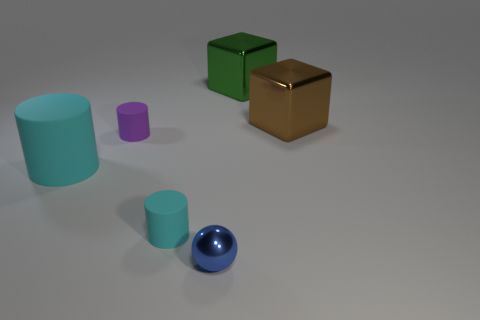There is a sphere that is the same size as the purple thing; what color is it?
Ensure brevity in your answer.  Blue. What size is the shiny object behind the large brown object?
Provide a short and direct response. Large. There is a big object on the left side of the blue ball; is there a tiny cyan cylinder on the right side of it?
Make the answer very short. Yes. Is the cyan cylinder right of the large cylinder made of the same material as the sphere?
Your response must be concise. No. What number of things are both to the right of the small cyan matte object and in front of the big brown thing?
Your answer should be compact. 1. What number of tiny yellow cylinders are made of the same material as the sphere?
Your response must be concise. 0. The other big block that is the same material as the big brown block is what color?
Make the answer very short. Green. Are there fewer small yellow metallic cylinders than cyan cylinders?
Ensure brevity in your answer.  Yes. The cube behind the large metal cube in front of the shiny cube that is behind the large brown cube is made of what material?
Your answer should be very brief. Metal. What is the big cylinder made of?
Offer a very short reply. Rubber. 